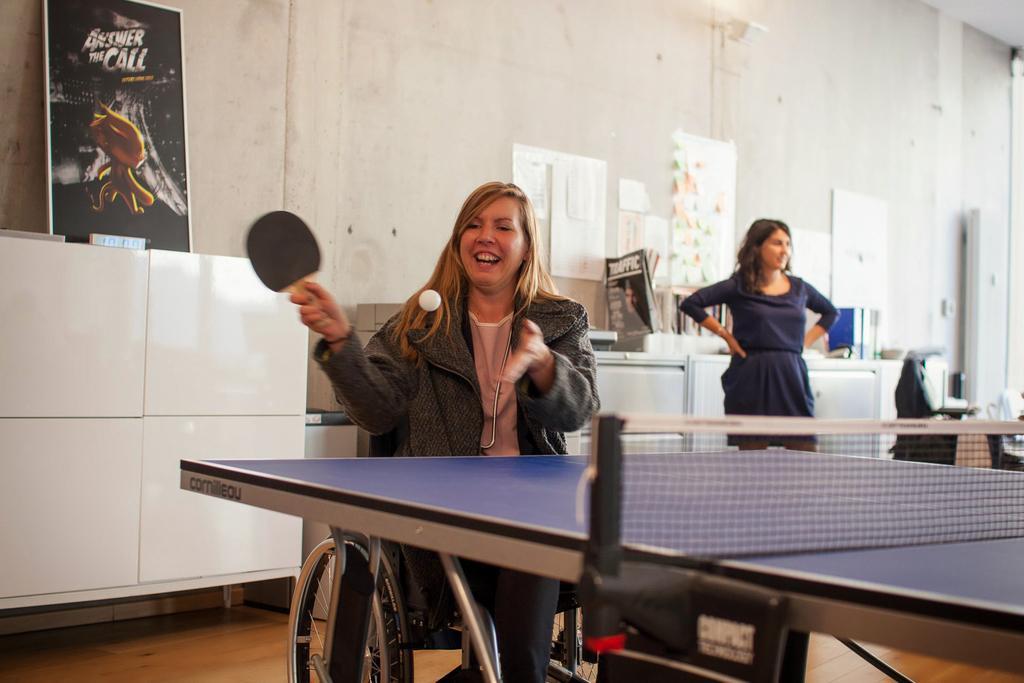Could you give a brief overview of what you see in this image? In this picture, we see woman in black jacket is playing table tennis and she is smiling, and she is sitting on wheelchair and beside her, we see a woman in blue dress standing and smiling. Behind her, we see white cupboard on which a board with man is placed on it and behind that, we see a white wall on which many white cards are placed. On the right left top of the picture, we see a board with some text written on it. 